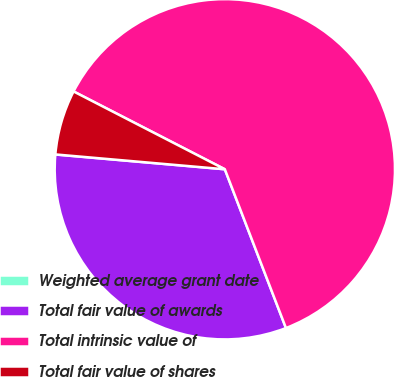Convert chart. <chart><loc_0><loc_0><loc_500><loc_500><pie_chart><fcel>Weighted average grant date<fcel>Total fair value of awards<fcel>Total intrinsic value of<fcel>Total fair value of shares<nl><fcel>0.01%<fcel>32.23%<fcel>61.59%<fcel>6.17%<nl></chart> 